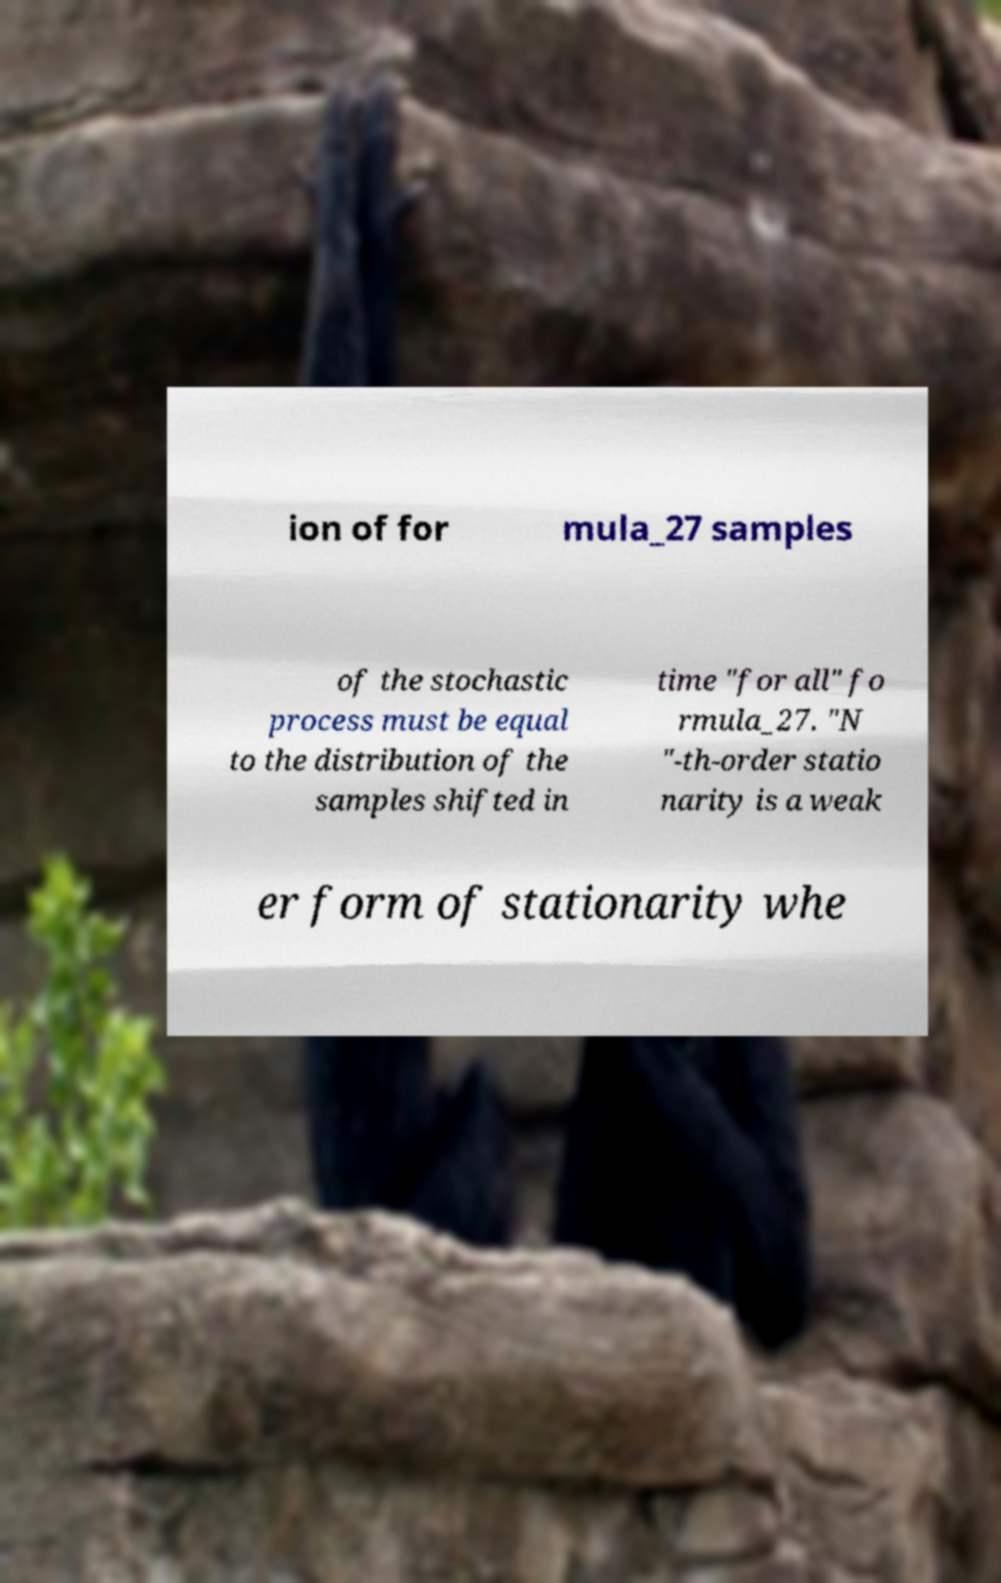There's text embedded in this image that I need extracted. Can you transcribe it verbatim? ion of for mula_27 samples of the stochastic process must be equal to the distribution of the samples shifted in time "for all" fo rmula_27. "N "-th-order statio narity is a weak er form of stationarity whe 